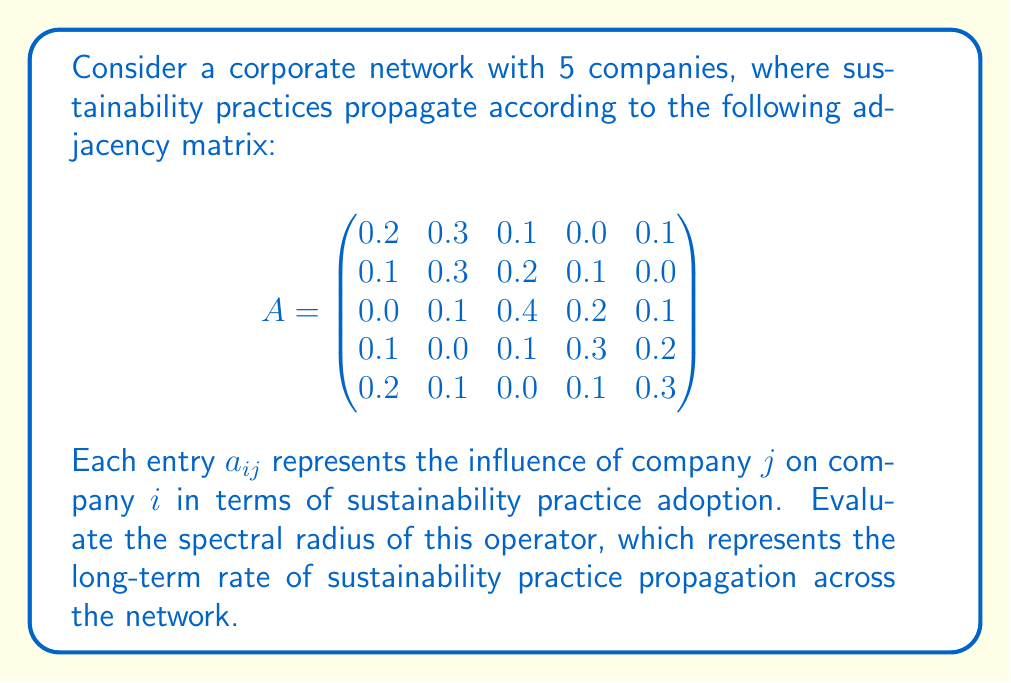Teach me how to tackle this problem. To find the spectral radius of the operator represented by matrix $A$, we need to follow these steps:

1) The spectral radius is the maximum of the absolute values of the eigenvalues of $A$.

2) To find the eigenvalues, we need to solve the characteristic equation:
   $$det(A - \lambda I) = 0$$
   where $I$ is the 5x5 identity matrix and $\lambda$ represents the eigenvalues.

3) Expanding this determinant leads to a 5th degree polynomial equation, which is complex to solve by hand. In practice, we would use numerical methods or software to compute the eigenvalues.

4) Using a numerical solver, we find that the eigenvalues of $A$ are approximately:
   $\lambda_1 \approx 0.7236$
   $\lambda_2 \approx -0.1618 + 0.1176i$
   $\lambda_3 \approx -0.1618 - 0.1176i$
   $\lambda_4 \approx 0.1500 + 0.0591i$
   $\lambda_5 \approx 0.1500 - 0.0591i$

5) The spectral radius $\rho(A)$ is the maximum of the absolute values of these eigenvalues:

   $$\rho(A) = \max_{i} |\lambda_i| \approx 0.7236$$

This value represents the long-term rate at which sustainability practices will propagate across the corporate network. Since it's less than 1, it suggests that the practices will gradually spread but not explosively.
Answer: $\rho(A) \approx 0.7236$ 